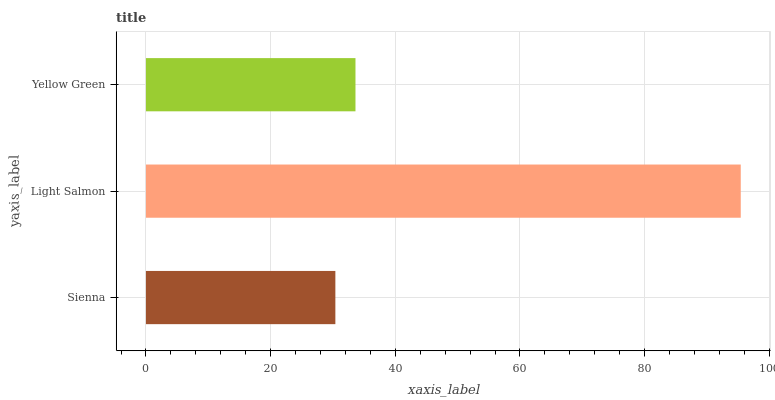Is Sienna the minimum?
Answer yes or no. Yes. Is Light Salmon the maximum?
Answer yes or no. Yes. Is Yellow Green the minimum?
Answer yes or no. No. Is Yellow Green the maximum?
Answer yes or no. No. Is Light Salmon greater than Yellow Green?
Answer yes or no. Yes. Is Yellow Green less than Light Salmon?
Answer yes or no. Yes. Is Yellow Green greater than Light Salmon?
Answer yes or no. No. Is Light Salmon less than Yellow Green?
Answer yes or no. No. Is Yellow Green the high median?
Answer yes or no. Yes. Is Yellow Green the low median?
Answer yes or no. Yes. Is Sienna the high median?
Answer yes or no. No. Is Sienna the low median?
Answer yes or no. No. 